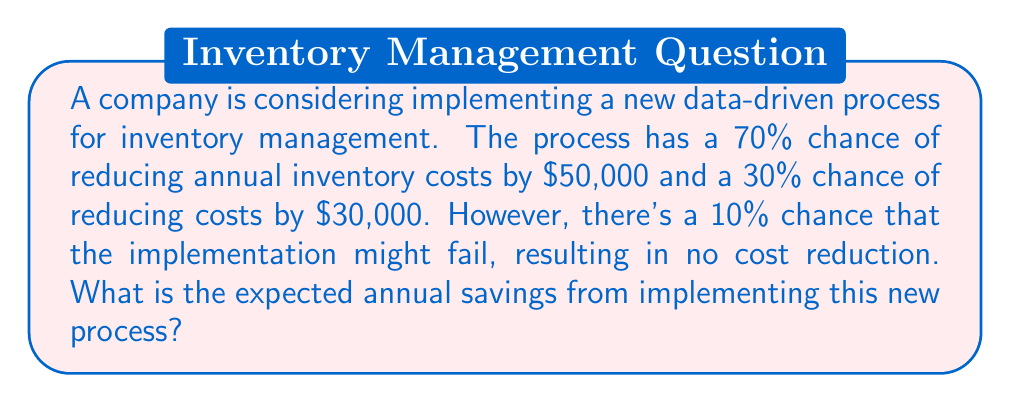Show me your answer to this math problem. To solve this problem, we need to calculate the expected value of the annual savings. Let's break it down step-by-step:

1. First, let's identify the possible outcomes and their probabilities:
   - 63% chance (70% * 90%) of saving $50,000
   - 27% chance (30% * 90%) of saving $30,000
   - 10% chance of saving $0 (implementation failure)

2. Now, let's calculate the expected value using the formula:
   $$ E(X) = \sum_{i=1}^{n} p_i x_i $$
   where $p_i$ is the probability of each outcome and $x_i$ is the value of each outcome.

3. Plugging in our values:
   $$ E(X) = (0.63 \times \$50,000) + (0.27 \times \$30,000) + (0.10 \times \$0) $$

4. Let's calculate each term:
   $$ E(X) = \$31,500 + \$8,100 + \$0 $$

5. Sum up the terms:
   $$ E(X) = \$39,600 $$

Therefore, the expected annual savings from implementing the new data-driven process is $39,600.
Answer: $39,600 